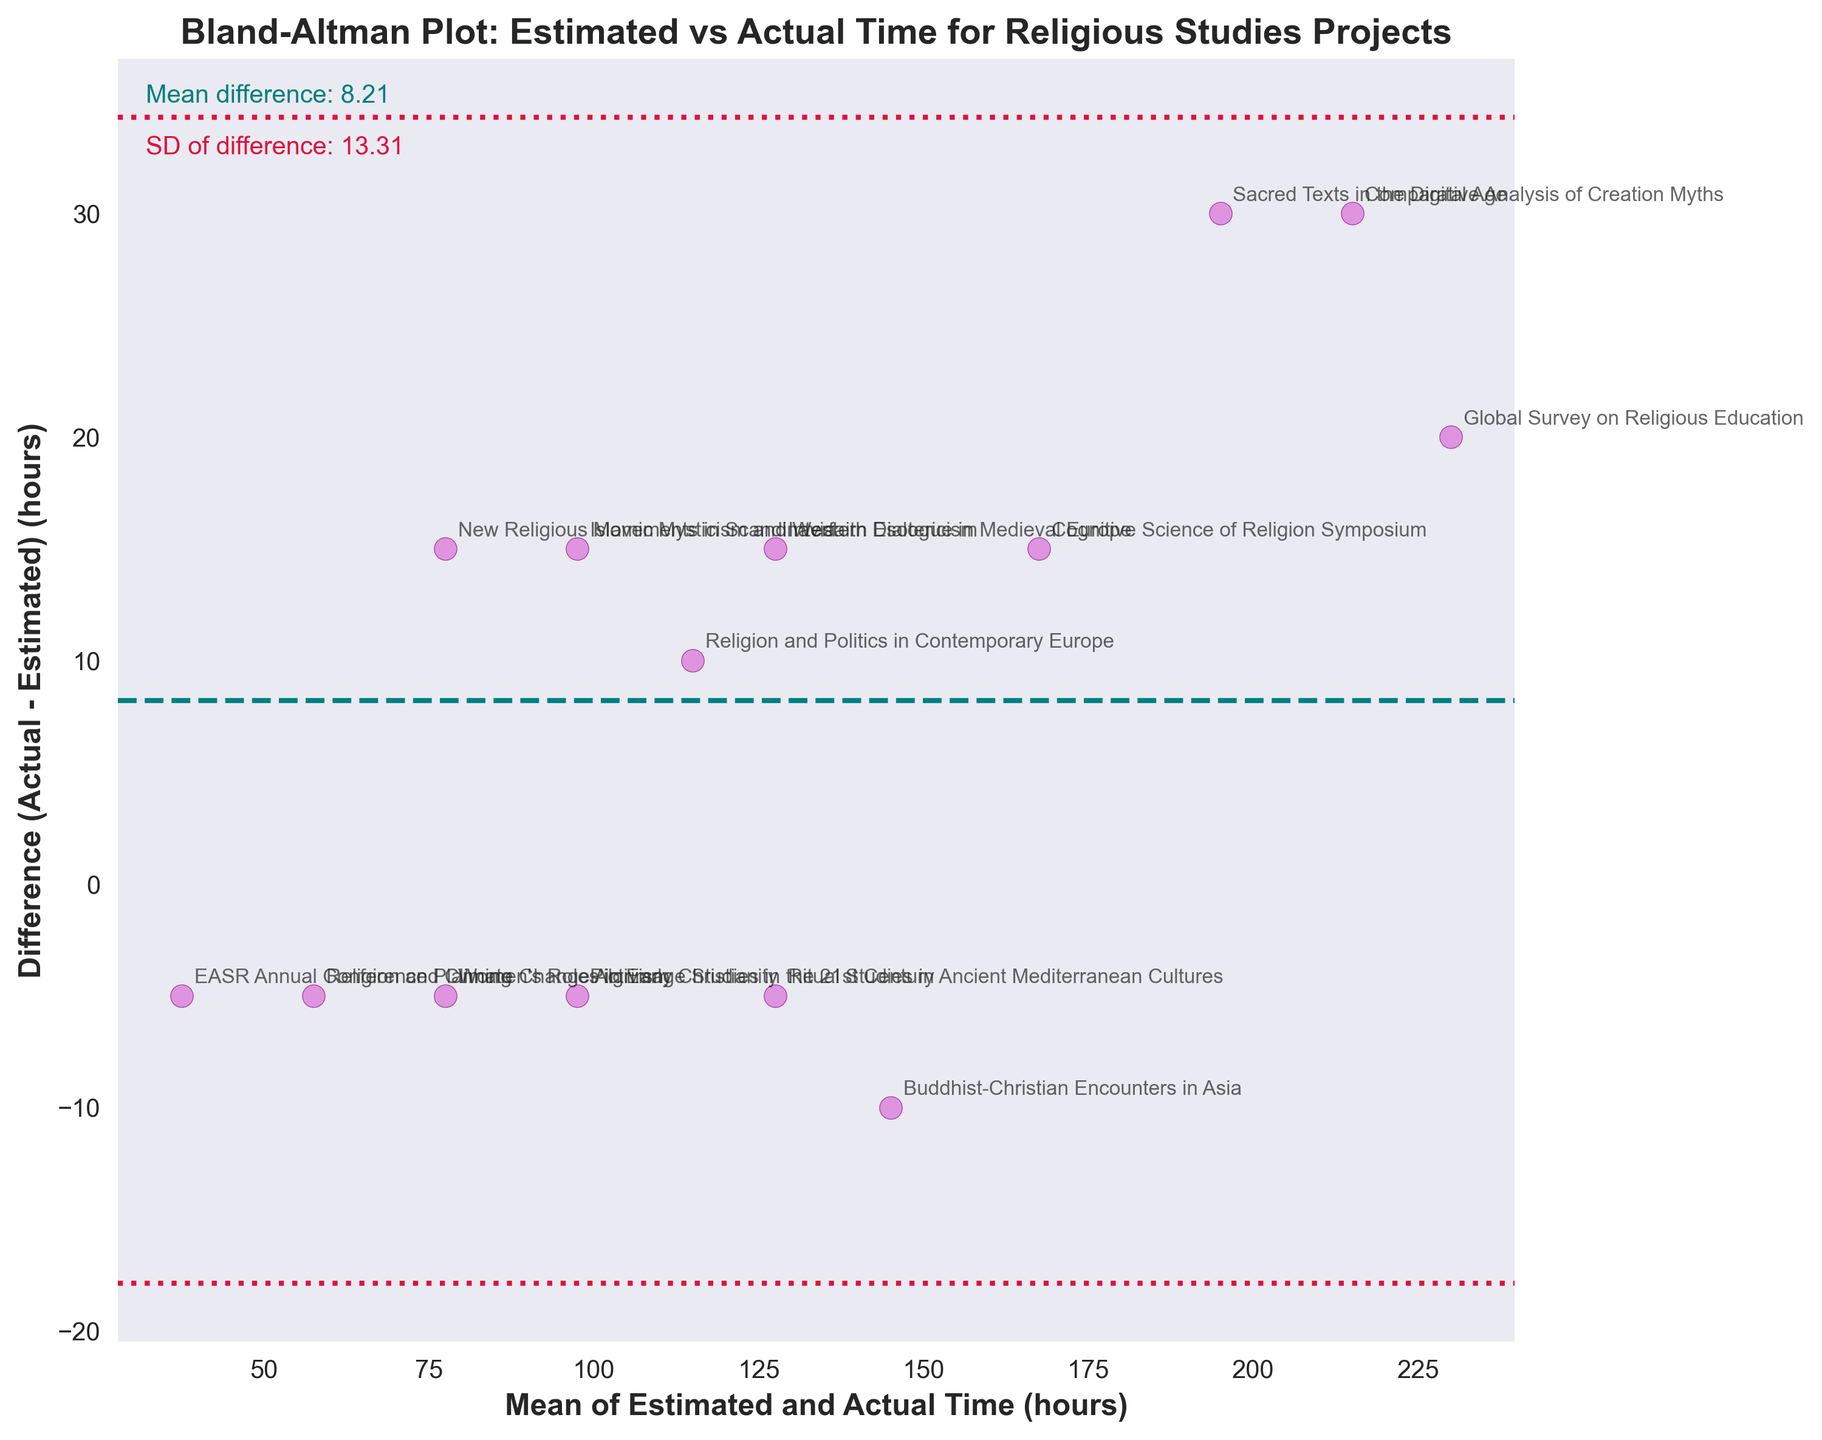What's the title of the figure? The title of the figure is written at the top and describes what the plot represents.
Answer: Bland-Altman Plot: Estimated vs Actual Time for Religious Studies Projects How many data points are plotted in the figure? Each project corresponds to one data point. Count the number of unique project names annotated near each data point.
Answer: 14 What do the horizontal dashed and dotted lines represent? The horizontal dashed line represents the mean difference between the actual and estimated times, while the horizontal dotted lines represent the limits of agreement, calculated as the mean difference plus or minus 1.96 times the standard deviation of the differences.
Answer: Mean difference and limits of agreement Which data point shows the largest underestimation in the estimated time compared to the actual time? Look for the data point with the most negative difference (difference closest to the bottom). The annotation near this point is "Interfaith Dialogue in Medieval Europe."
Answer: Interfaith Dialogue in Medieval Europe What is the mean difference between the actual and estimated times? The mean difference is explicitly shown in the text on the figure near the bottom.
Answer: 13.21 Considering the project 'Global Survey on Religious Education', does it have a positive or negative difference between actual and estimated times? Look for the specific annotated point for 'Global Survey on Religious Education' and check if it is above or below the horizontal dashed line (mean difference line).
Answer: Positive Between which two values do the limits of agreement lie? The limits of agreement are the dashed horizontal lines above and below the mean difference. Add and subtract 1.96 times the standard deviation from the mean difference to find these limits.
Answer: -2.04 and 28.45 What project name is associated with a mean of about 120 hours and a difference of 10 hours? Find the point closest to the coordinates (120, 10) and note the associated project name in the figure.
Answer: Pilgrimage Studies in the 21st Century Does the project 'Buddhist-Christian Encounters in Asia' lie within the limits of agreement? Locate the project name 'Buddhist-Christian Encounters in Asia' and check if the associated point lies between the horizontal dotted lines.
Answer: Yes Compare 'Comparative Analysis of Creation Myths' and 'Islamic Mysticism and Western Esotericism' in terms of their differences. Which project has a larger difference? Identify the annotated points for both projects and compare their positions. The one further from the mean difference line has the larger difference.
Answer: Comparative Analysis of Creation Myths 